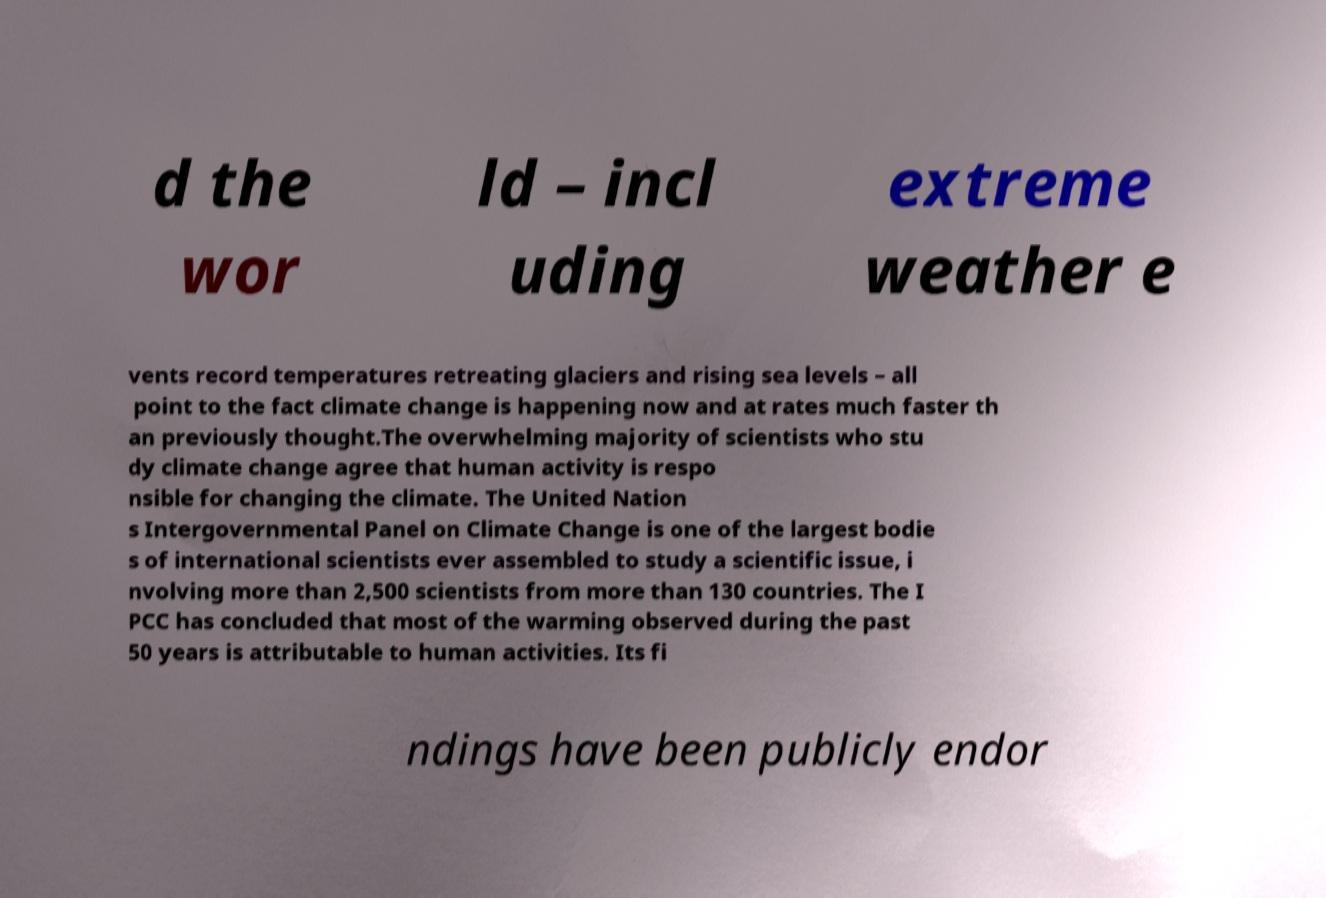What messages or text are displayed in this image? I need them in a readable, typed format. d the wor ld – incl uding extreme weather e vents record temperatures retreating glaciers and rising sea levels – all point to the fact climate change is happening now and at rates much faster th an previously thought.The overwhelming majority of scientists who stu dy climate change agree that human activity is respo nsible for changing the climate. The United Nation s Intergovernmental Panel on Climate Change is one of the largest bodie s of international scientists ever assembled to study a scientific issue, i nvolving more than 2,500 scientists from more than 130 countries. The I PCC has concluded that most of the warming observed during the past 50 years is attributable to human activities. Its fi ndings have been publicly endor 